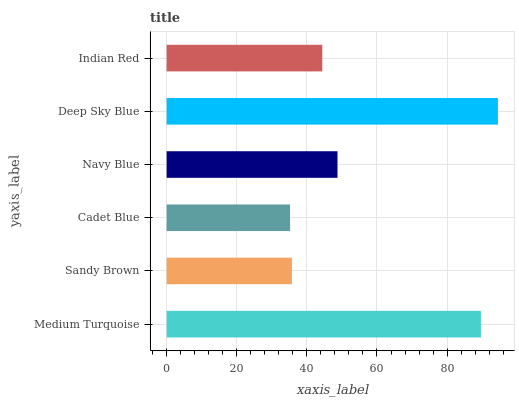Is Cadet Blue the minimum?
Answer yes or no. Yes. Is Deep Sky Blue the maximum?
Answer yes or no. Yes. Is Sandy Brown the minimum?
Answer yes or no. No. Is Sandy Brown the maximum?
Answer yes or no. No. Is Medium Turquoise greater than Sandy Brown?
Answer yes or no. Yes. Is Sandy Brown less than Medium Turquoise?
Answer yes or no. Yes. Is Sandy Brown greater than Medium Turquoise?
Answer yes or no. No. Is Medium Turquoise less than Sandy Brown?
Answer yes or no. No. Is Navy Blue the high median?
Answer yes or no. Yes. Is Indian Red the low median?
Answer yes or no. Yes. Is Medium Turquoise the high median?
Answer yes or no. No. Is Navy Blue the low median?
Answer yes or no. No. 